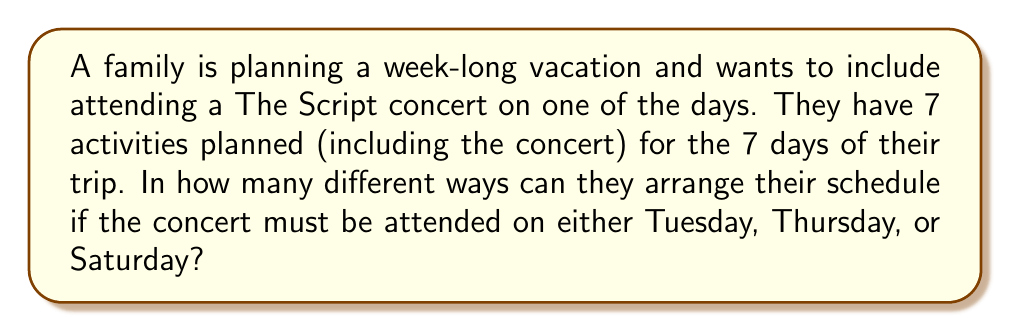Solve this math problem. Let's approach this step-by-step:

1) First, we need to consider the placement of the concert. We have 3 options for this (Tuesday, Thursday, or Saturday).

2) Once we've placed the concert, we need to arrange the remaining 6 activities in the 6 remaining days.

3) The number of ways to arrange 6 activities in 6 days is a straightforward permutation: $P(6,6) = 6!$

4) For each of the 3 possible concert placements, we have $6!$ ways to arrange the other activities.

5) Therefore, we can use the multiplication principle. The total number of possible schedules is:

   $$ 3 \times 6! $$

6) Let's calculate this:
   $$ 3 \times 6! = 3 \times (6 \times 5 \times 4 \times 3 \times 2 \times 1) = 3 \times 720 = 2160 $$

Thus, there are 2160 different possible schedules for the family's vacation.
Answer: 2160 